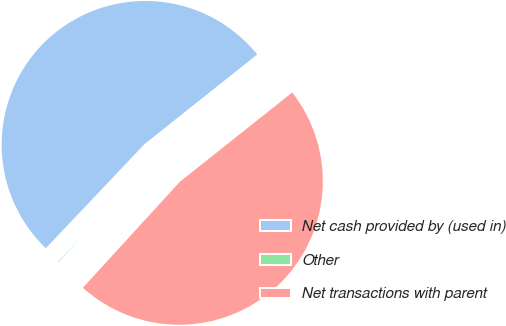Convert chart. <chart><loc_0><loc_0><loc_500><loc_500><pie_chart><fcel>Net cash provided by (used in)<fcel>Other<fcel>Net transactions with parent<nl><fcel>52.23%<fcel>0.28%<fcel>47.48%<nl></chart> 